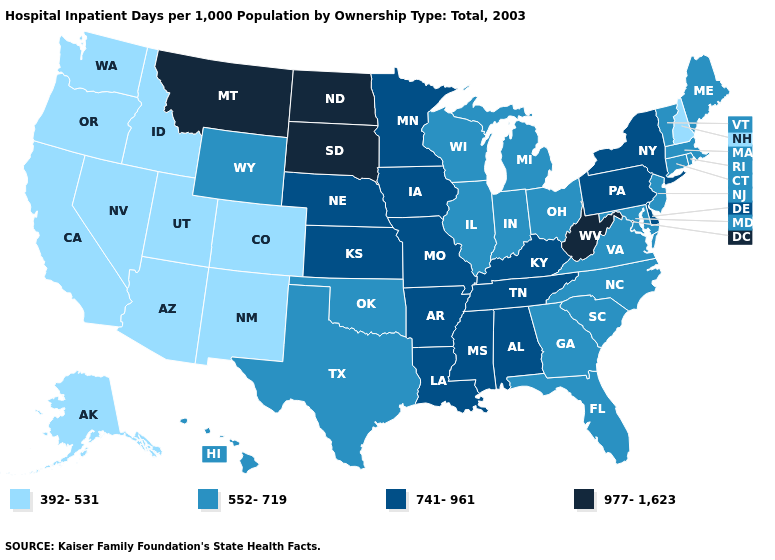Among the states that border Maryland , does Virginia have the highest value?
Write a very short answer. No. Does Alaska have a lower value than Arizona?
Be succinct. No. What is the value of Pennsylvania?
Answer briefly. 741-961. Is the legend a continuous bar?
Write a very short answer. No. Name the states that have a value in the range 392-531?
Be succinct. Alaska, Arizona, California, Colorado, Idaho, Nevada, New Hampshire, New Mexico, Oregon, Utah, Washington. What is the value of Wyoming?
Be succinct. 552-719. What is the value of Maine?
Be succinct. 552-719. What is the value of Iowa?
Keep it brief. 741-961. Which states have the lowest value in the South?
Quick response, please. Florida, Georgia, Maryland, North Carolina, Oklahoma, South Carolina, Texas, Virginia. Name the states that have a value in the range 977-1,623?
Answer briefly. Montana, North Dakota, South Dakota, West Virginia. What is the lowest value in the USA?
Quick response, please. 392-531. Name the states that have a value in the range 392-531?
Concise answer only. Alaska, Arizona, California, Colorado, Idaho, Nevada, New Hampshire, New Mexico, Oregon, Utah, Washington. What is the value of Virginia?
Short answer required. 552-719. Does the first symbol in the legend represent the smallest category?
Short answer required. Yes. What is the value of Arkansas?
Give a very brief answer. 741-961. 